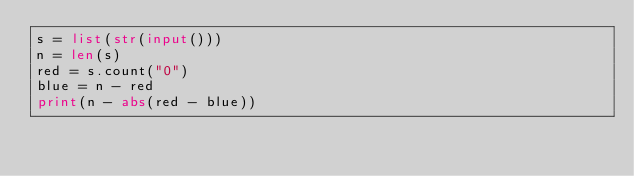<code> <loc_0><loc_0><loc_500><loc_500><_Python_>s = list(str(input()))
n = len(s)
red = s.count("0")
blue = n - red
print(n - abs(red - blue))</code> 